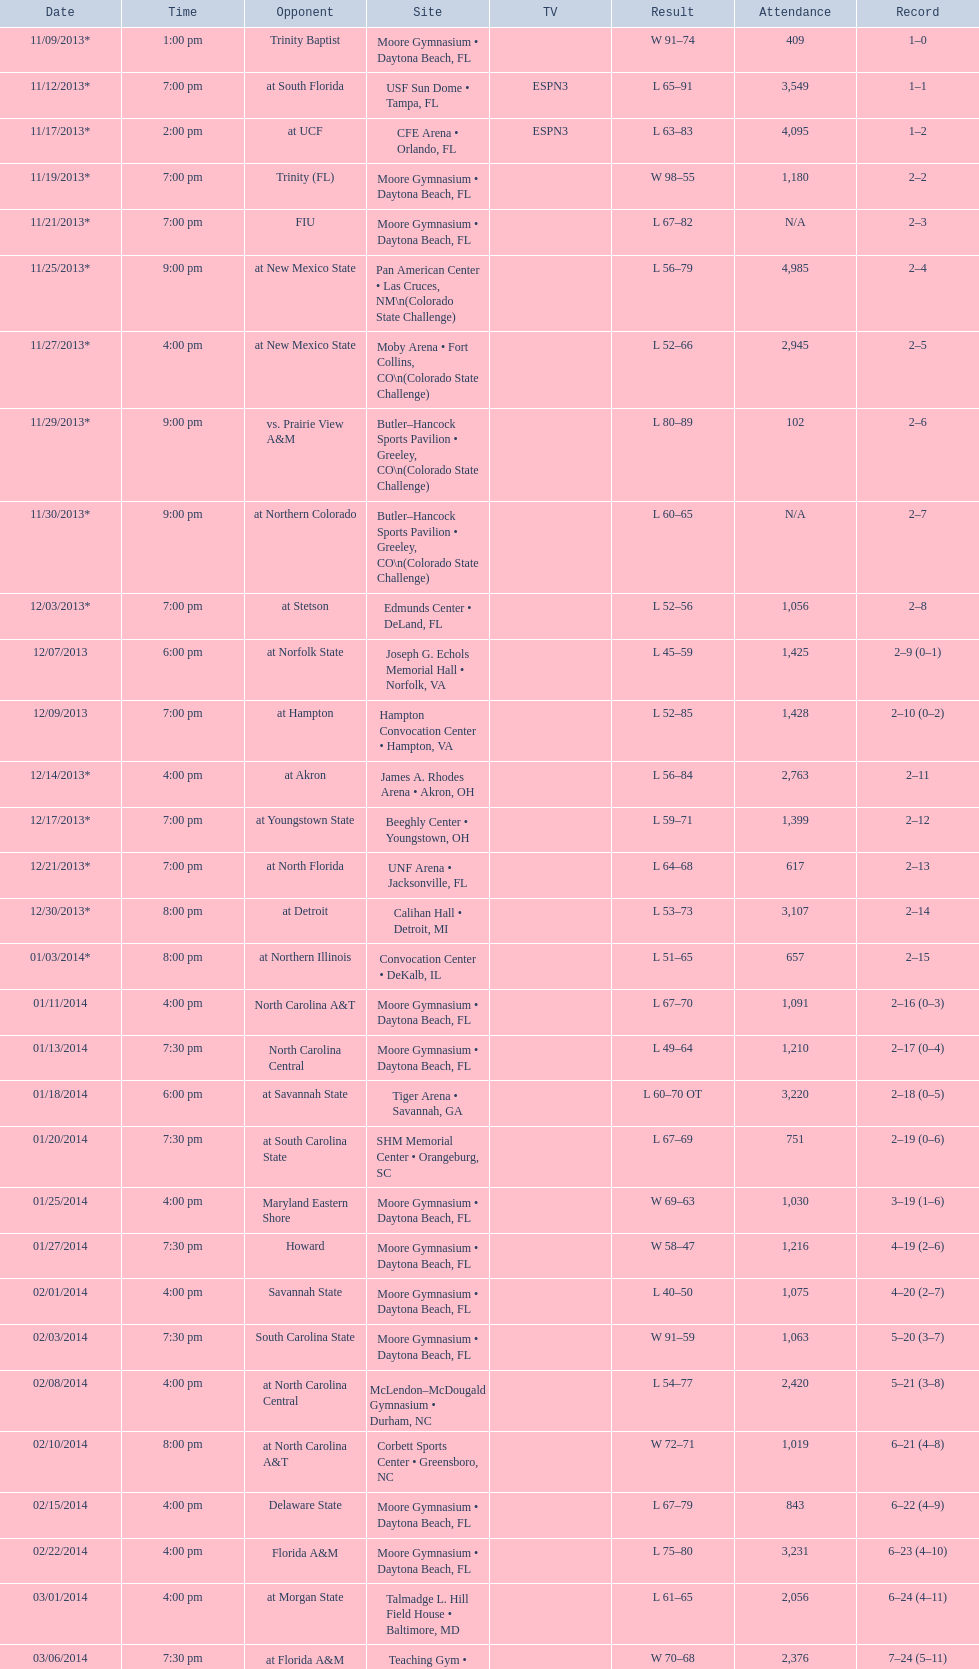How much larger was the attendance on 11/25/2013 than 12/21/2013? 4368. 